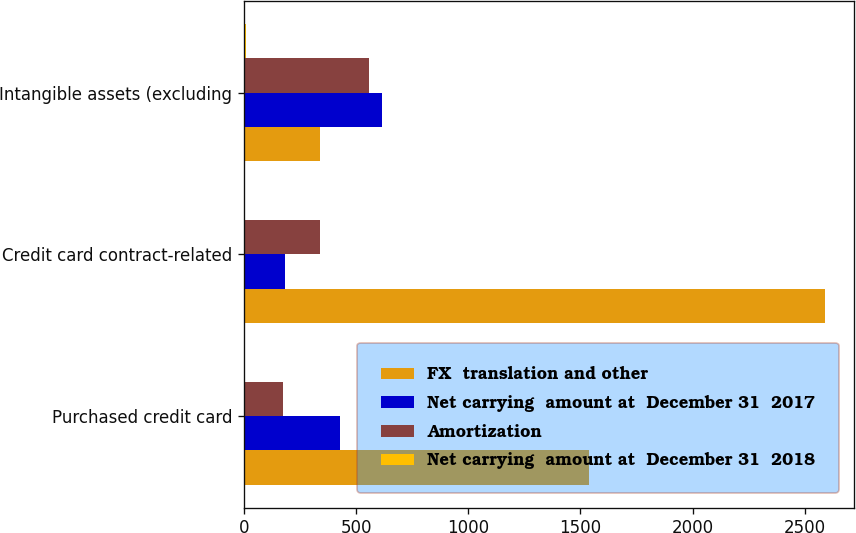Convert chart to OTSL. <chart><loc_0><loc_0><loc_500><loc_500><stacked_bar_chart><ecel><fcel>Purchased credit card<fcel>Credit card contract-related<fcel>Intangible assets (excluding<nl><fcel>FX  translation and other<fcel>1539<fcel>2589<fcel>339<nl><fcel>Net carrying  amount at  December 31  2017<fcel>429<fcel>185<fcel>614<nl><fcel>Amortization<fcel>173<fcel>339<fcel>557<nl><fcel>Net carrying  amount at  December 31  2018<fcel>2<fcel>1<fcel>9<nl></chart> 